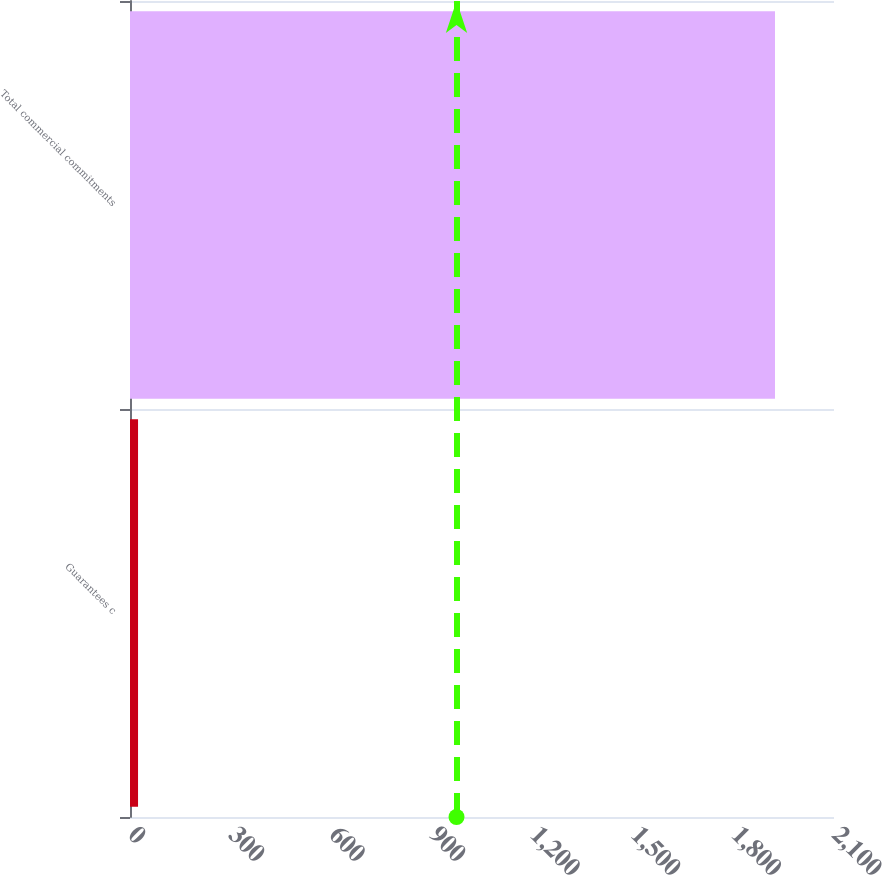Convert chart. <chart><loc_0><loc_0><loc_500><loc_500><bar_chart><fcel>Guarantees c<fcel>Total commercial commitments<nl><fcel>24<fcel>1924<nl></chart> 